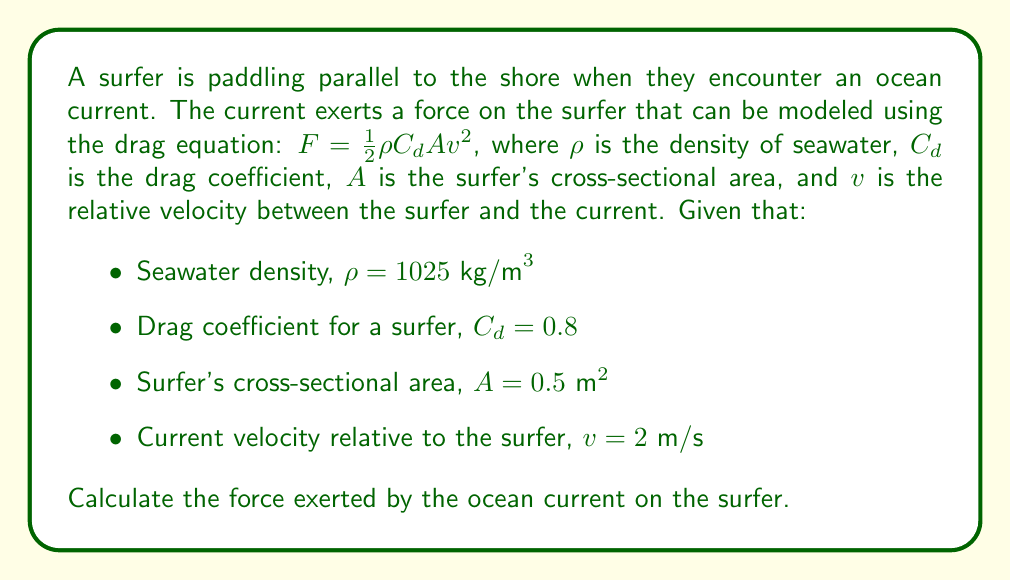Show me your answer to this math problem. To solve this problem, we'll use the drag equation and plug in the given values:

1) The drag equation is:
   $$F = \frac{1}{2} \rho C_d A v^2$$

2) We have the following values:
   - $\rho = 1025 \text{ kg/m}^3$
   - $C_d = 0.8$
   - $A = 0.5 \text{ m}^2$
   - $v = 2 \text{ m/s}$

3) Let's substitute these values into the equation:
   $$F = \frac{1}{2} (1025 \text{ kg/m}^3) (0.8) (0.5 \text{ m}^2) (2 \text{ m/s})^2$$

4) First, let's calculate $v^2$:
   $$(2 \text{ m/s})^2 = 4 \text{ m}^2/\text{s}^2$$

5) Now, let's multiply all the values:
   $$F = \frac{1}{2} \times 1025 \times 0.8 \times 0.5 \times 4$$
   $$F = 820 \text{ kg} \cdot \text{m}/\text{s}^2$$

6) The unit kg·m/s^2 is equivalent to Newtons (N), so we can express the final answer in Newtons.
Answer: The force exerted by the ocean current on the surfer is 820 N. 